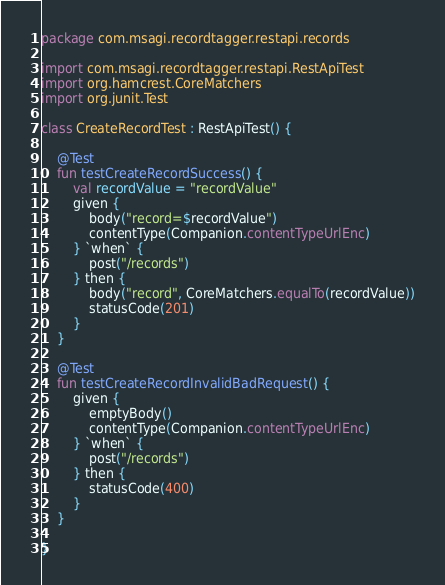<code> <loc_0><loc_0><loc_500><loc_500><_Kotlin_>package com.msagi.recordtagger.restapi.records

import com.msagi.recordtagger.restapi.RestApiTest
import org.hamcrest.CoreMatchers
import org.junit.Test

class CreateRecordTest : RestApiTest() {

    @Test
    fun testCreateRecordSuccess() {
        val recordValue = "recordValue"
        given {
            body("record=$recordValue")
            contentType(Companion.contentTypeUrlEnc)
        } `when` {
            post("/records")
        } then {
            body("record", CoreMatchers.equalTo(recordValue))
            statusCode(201)
        }
    }

    @Test
    fun testCreateRecordInvalidBadRequest() {
        given {
            emptyBody()
            contentType(Companion.contentTypeUrlEnc)
        } `when` {
            post("/records")
        } then {
            statusCode(400)
        }
    }

}
</code> 